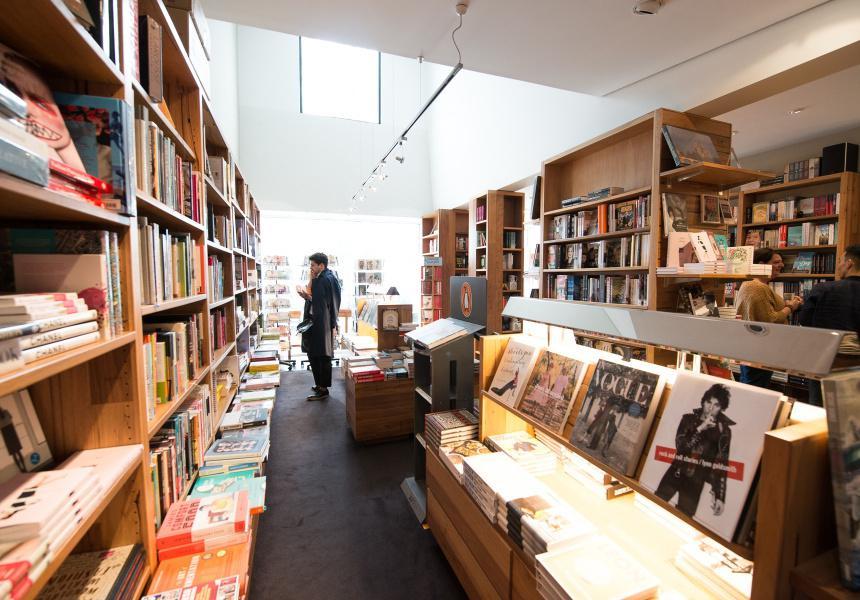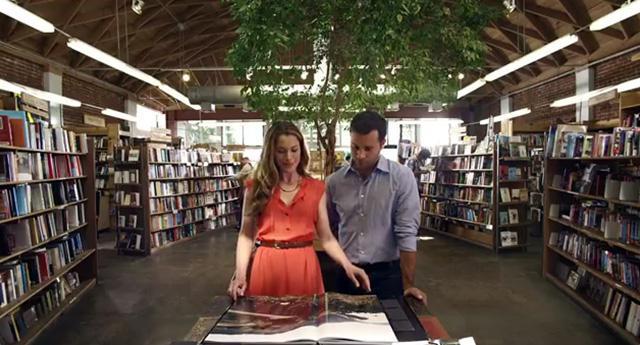The first image is the image on the left, the second image is the image on the right. Analyze the images presented: Is the assertion "The left and right images show someone standing at the end of an aisle of books, but not in front of a table display." valid? Answer yes or no. No. 